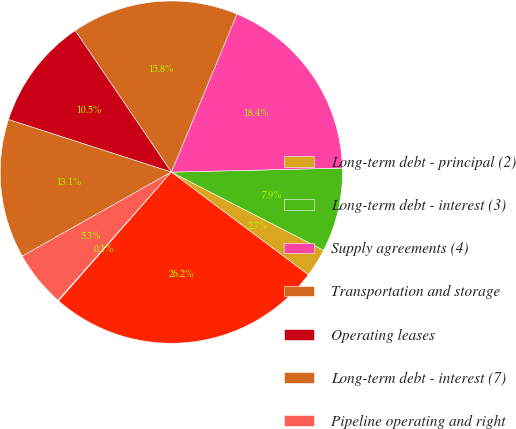Convert chart to OTSL. <chart><loc_0><loc_0><loc_500><loc_500><pie_chart><fcel>Long-term debt - principal (2)<fcel>Long-term debt - interest (3)<fcel>Supply agreements (4)<fcel>Transportation and storage<fcel>Operating leases<fcel>Long-term debt - interest (7)<fcel>Pipeline operating and right<fcel>Other agreements<fcel>Total<nl><fcel>2.69%<fcel>7.92%<fcel>18.37%<fcel>15.76%<fcel>10.53%<fcel>13.14%<fcel>5.31%<fcel>0.08%<fcel>26.21%<nl></chart> 